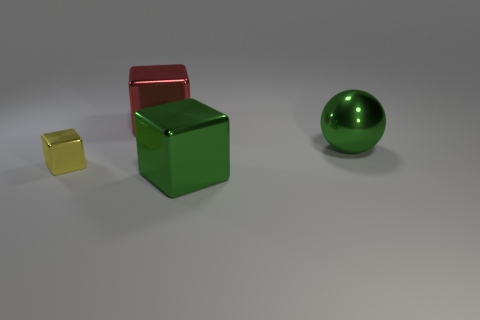The object that is both to the right of the large red metal thing and behind the big green block has what shape?
Give a very brief answer. Sphere. What is the color of the small thing that is made of the same material as the large green sphere?
Provide a short and direct response. Yellow. There is a green object that is in front of the green object to the right of the big metal block that is on the right side of the big red shiny thing; what shape is it?
Offer a terse response. Cube. There is a small thing that is made of the same material as the big green block; what shape is it?
Offer a very short reply. Cube. There is a metal block in front of the tiny shiny block; what color is it?
Your answer should be compact. Green. There is a cube that is the same color as the large metallic sphere; what material is it?
Your answer should be compact. Metal. What is the material of the cube that is the same size as the red object?
Keep it short and to the point. Metal. There is a green thing that is on the right side of the big cube in front of the object behind the metal ball; what is it made of?
Offer a terse response. Metal. Do the green metallic thing that is behind the green block and the large green shiny block have the same size?
Ensure brevity in your answer.  Yes. What number of other objects are there of the same color as the ball?
Your answer should be very brief. 1. 